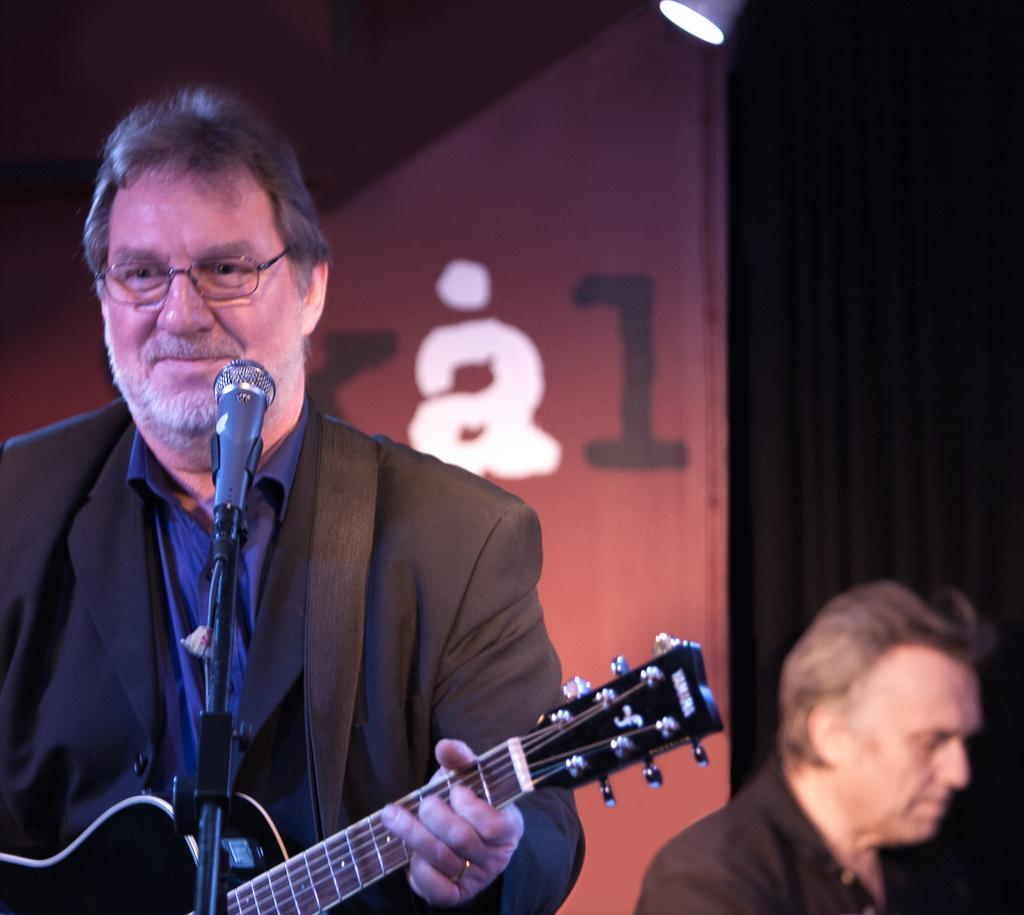How many people are in the image? There are two men in the image. What is one of the men holding? One of the men is holding a guitar. How does the man holding the guitar appear to feel? The man holding the guitar has a smile on his face, suggesting he is happy or enjoying himself. What accessory is the man holding the guitar wearing? The man holding the guitar is wearing glasses (specs). What object is in front of the man holding the guitar? There is a microphone (mic) in front of the man holding the guitar. What grade is the kettle in the image? There is no kettle present in the image. How does the man holding the guitar show care for the microphone? The image does not show any specific actions or behaviors that indicate the man is showing care for the microphone. 